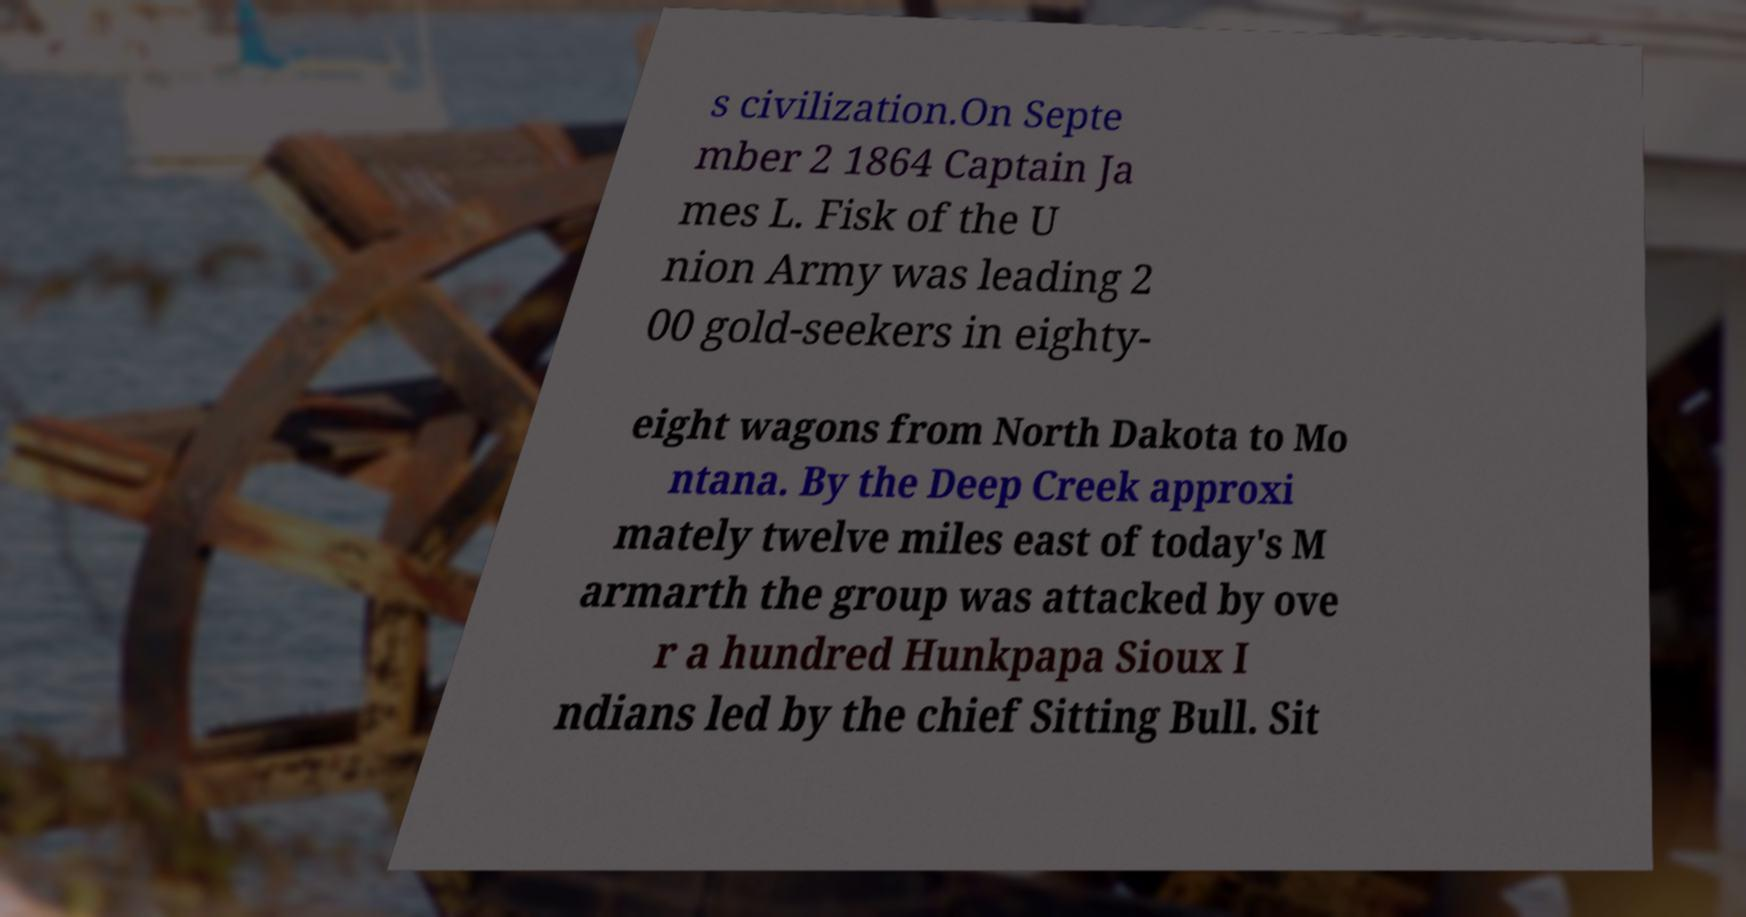Can you accurately transcribe the text from the provided image for me? s civilization.On Septe mber 2 1864 Captain Ja mes L. Fisk of the U nion Army was leading 2 00 gold-seekers in eighty- eight wagons from North Dakota to Mo ntana. By the Deep Creek approxi mately twelve miles east of today's M armarth the group was attacked by ove r a hundred Hunkpapa Sioux I ndians led by the chief Sitting Bull. Sit 